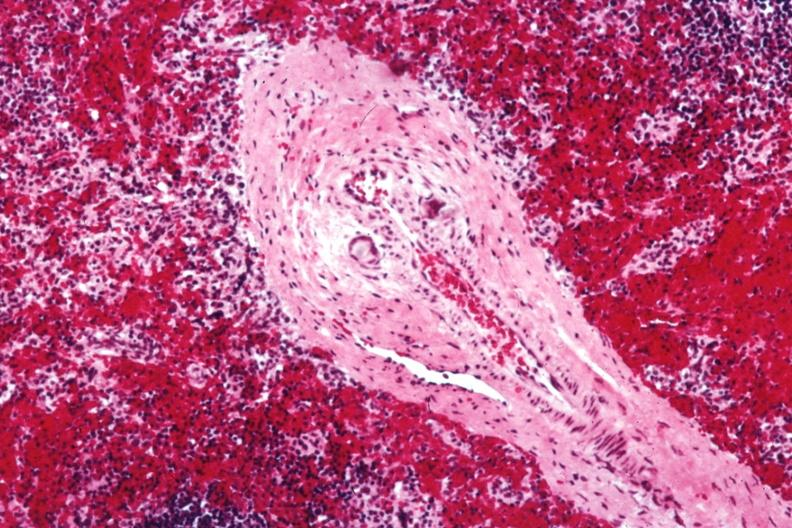what is postoperative cardiac surgery thought?
Answer the question using a single word or phrase. To be silicon 